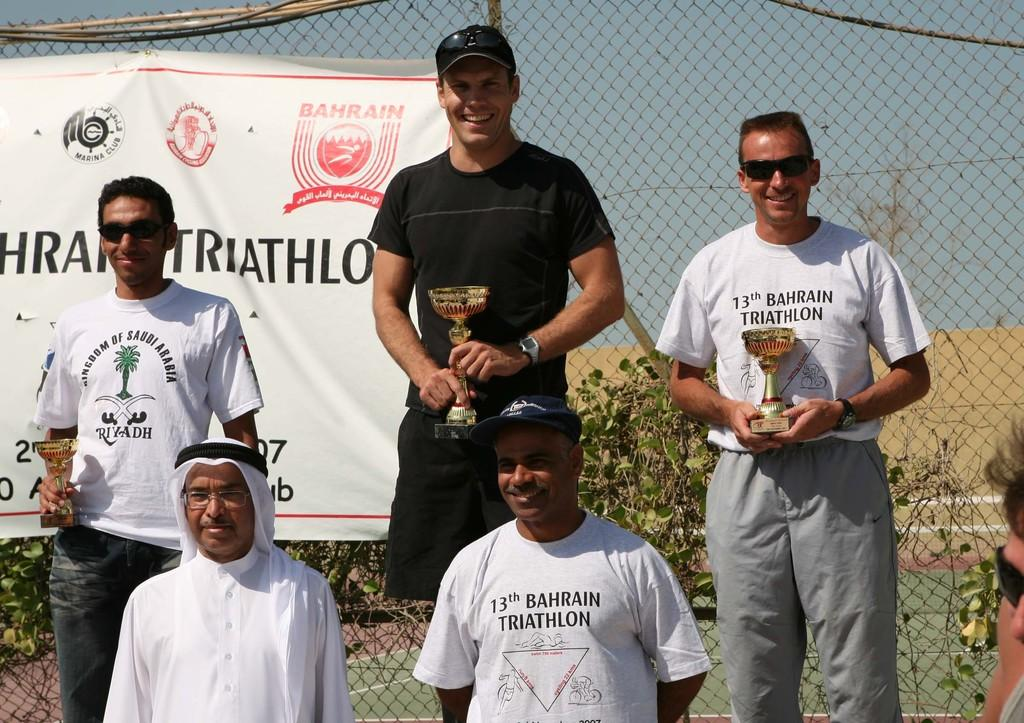<image>
Provide a brief description of the given image. People posing for a photo with one whose shirt says 13th. 